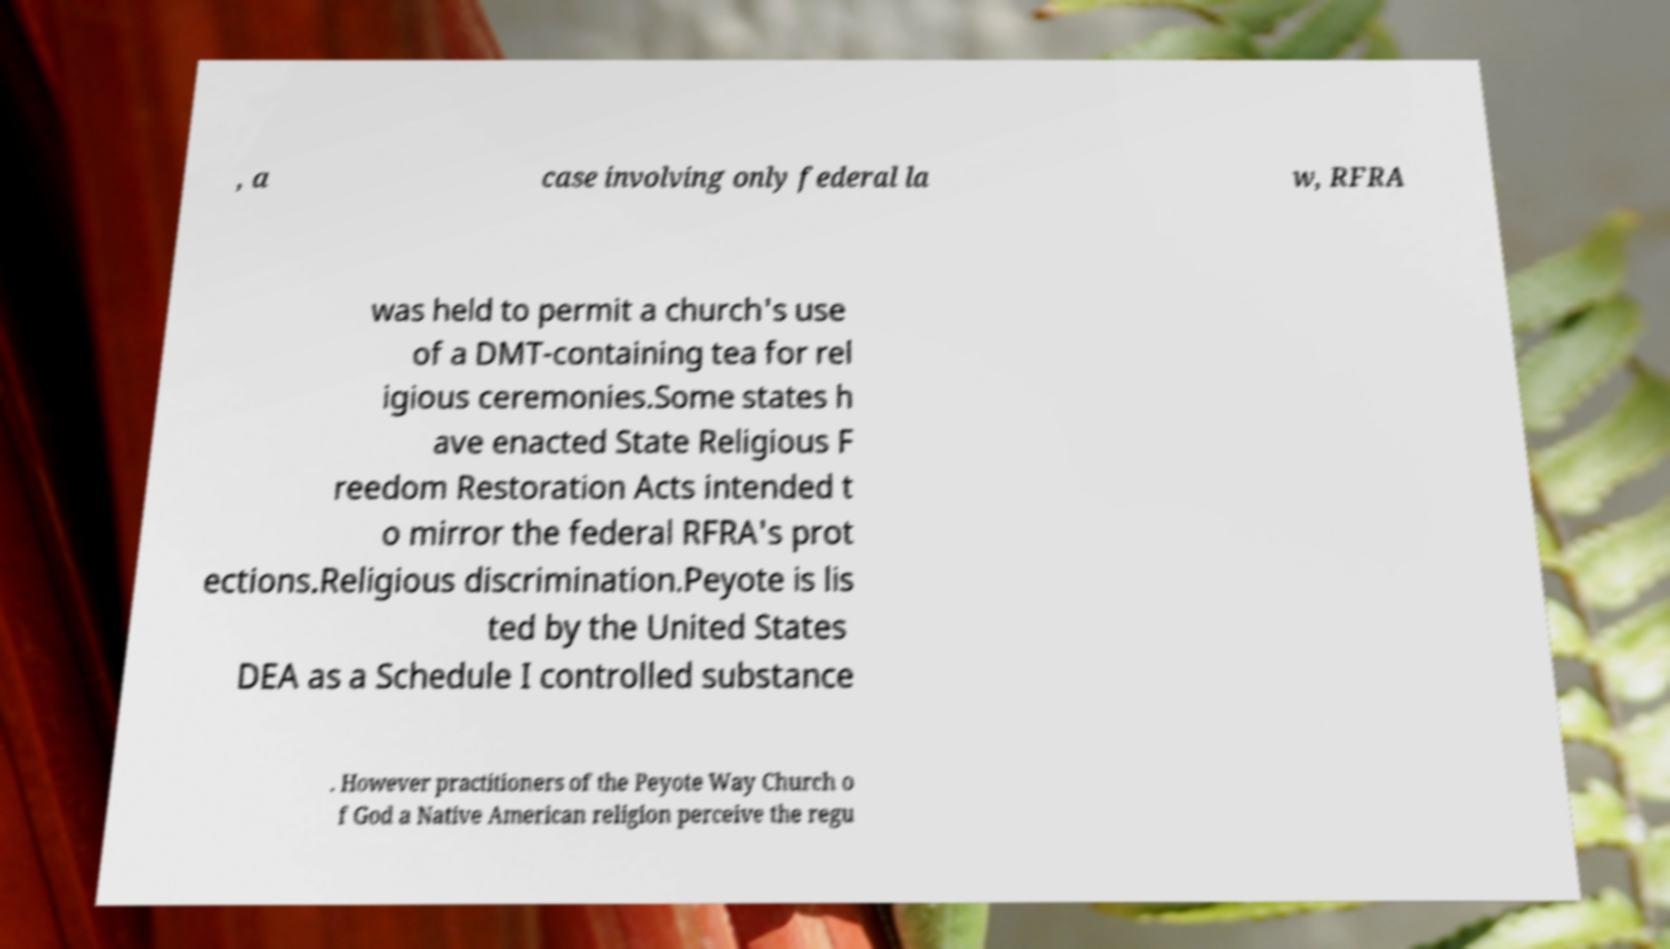For documentation purposes, I need the text within this image transcribed. Could you provide that? , a case involving only federal la w, RFRA was held to permit a church's use of a DMT-containing tea for rel igious ceremonies.Some states h ave enacted State Religious F reedom Restoration Acts intended t o mirror the federal RFRA's prot ections.Religious discrimination.Peyote is lis ted by the United States DEA as a Schedule I controlled substance . However practitioners of the Peyote Way Church o f God a Native American religion perceive the regu 